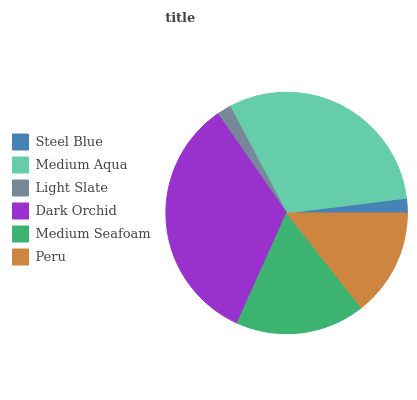Is Light Slate the minimum?
Answer yes or no. Yes. Is Dark Orchid the maximum?
Answer yes or no. Yes. Is Medium Aqua the minimum?
Answer yes or no. No. Is Medium Aqua the maximum?
Answer yes or no. No. Is Medium Aqua greater than Steel Blue?
Answer yes or no. Yes. Is Steel Blue less than Medium Aqua?
Answer yes or no. Yes. Is Steel Blue greater than Medium Aqua?
Answer yes or no. No. Is Medium Aqua less than Steel Blue?
Answer yes or no. No. Is Medium Seafoam the high median?
Answer yes or no. Yes. Is Peru the low median?
Answer yes or no. Yes. Is Medium Aqua the high median?
Answer yes or no. No. Is Steel Blue the low median?
Answer yes or no. No. 